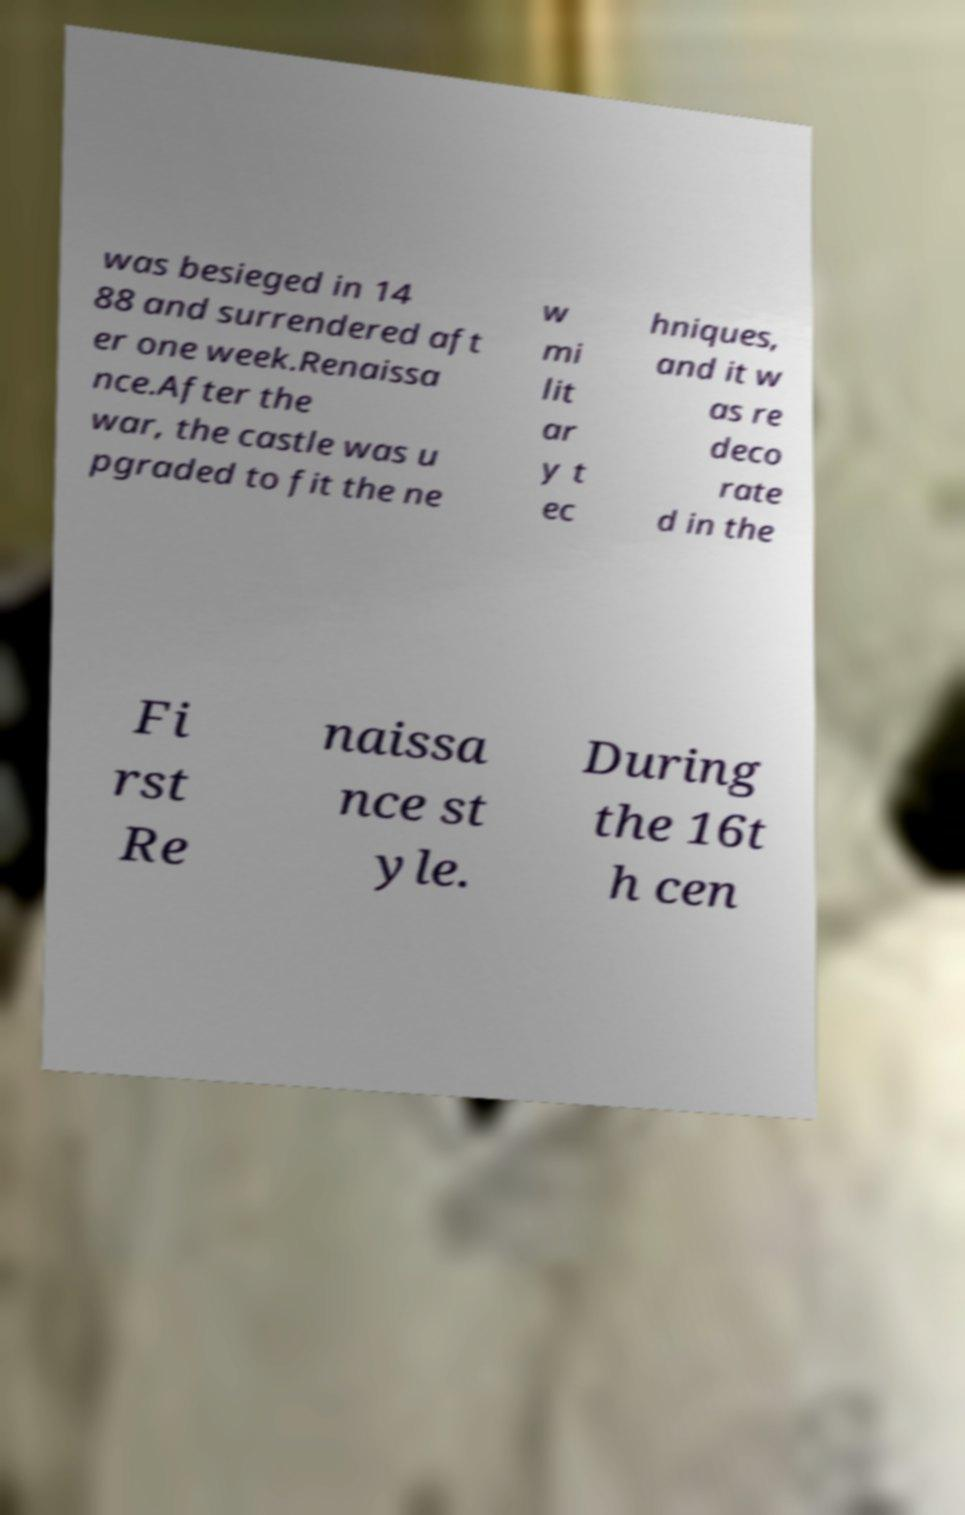Please identify and transcribe the text found in this image. was besieged in 14 88 and surrendered aft er one week.Renaissa nce.After the war, the castle was u pgraded to fit the ne w mi lit ar y t ec hniques, and it w as re deco rate d in the Fi rst Re naissa nce st yle. During the 16t h cen 